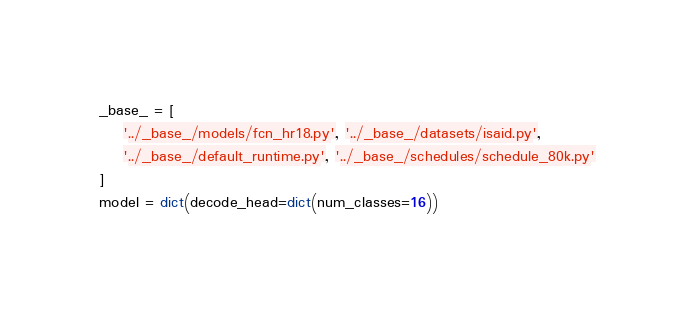<code> <loc_0><loc_0><loc_500><loc_500><_Python_>_base_ = [
    '../_base_/models/fcn_hr18.py', '../_base_/datasets/isaid.py',
    '../_base_/default_runtime.py', '../_base_/schedules/schedule_80k.py'
]
model = dict(decode_head=dict(num_classes=16))
</code> 